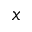Convert formula to latex. <formula><loc_0><loc_0><loc_500><loc_500>x</formula> 